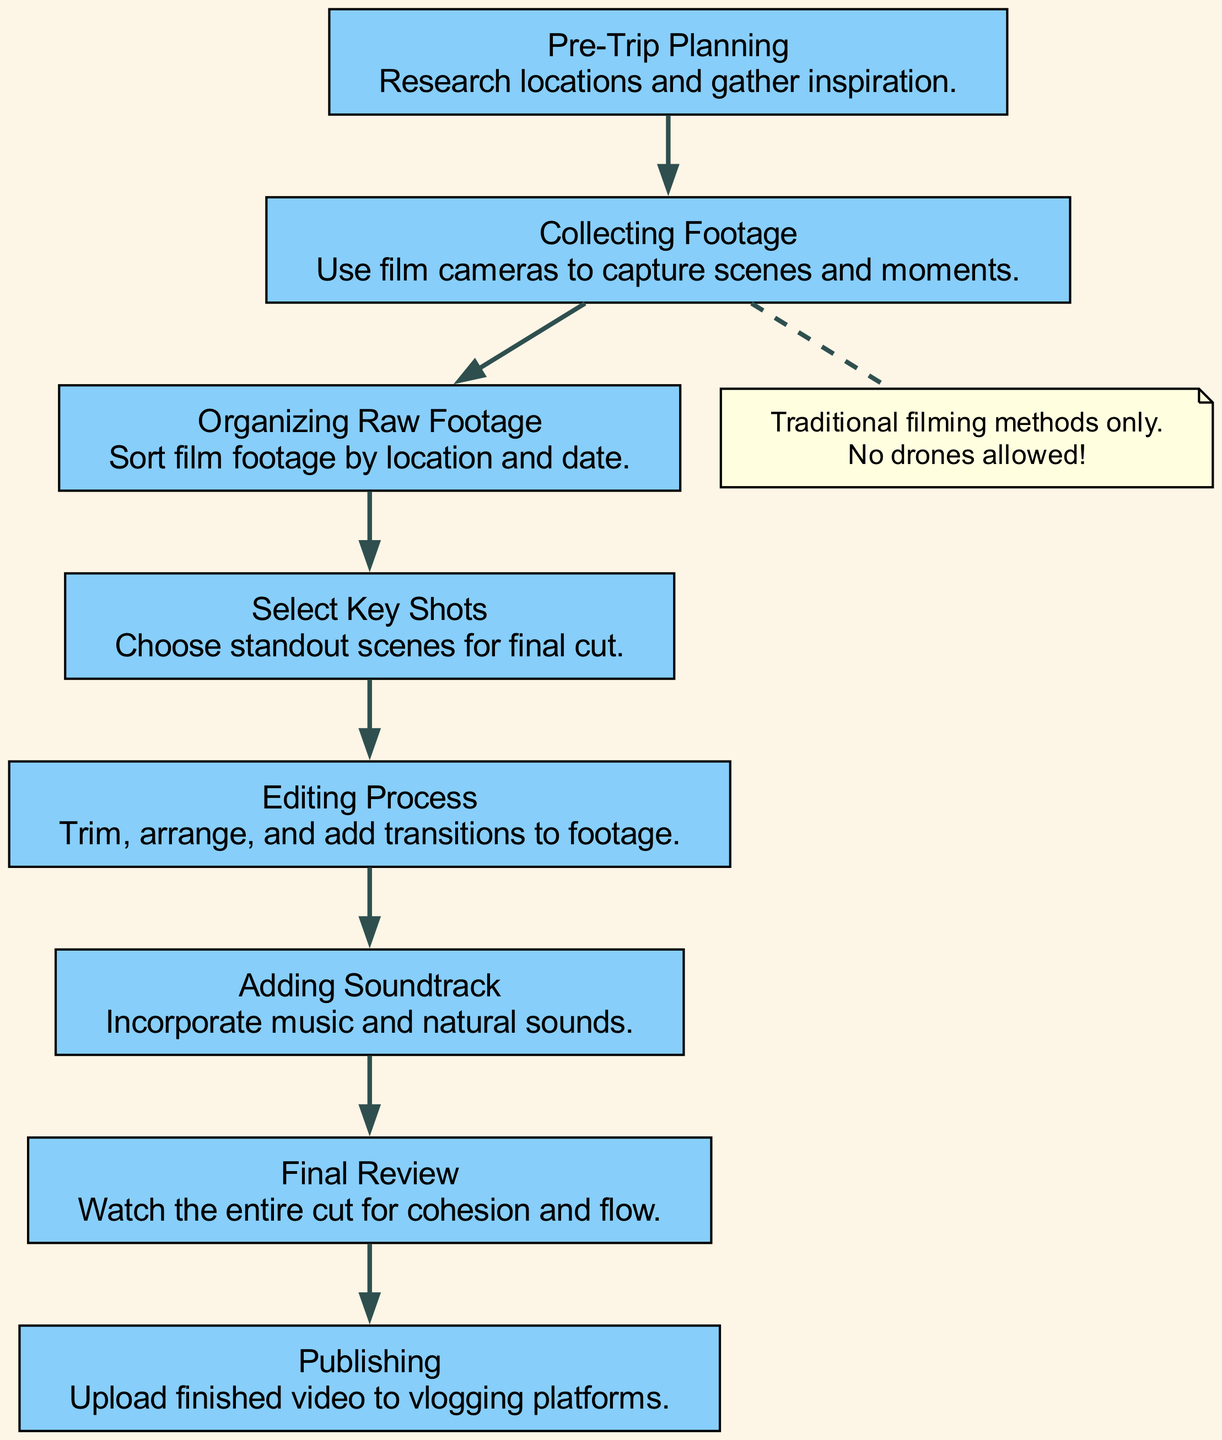What is the first step in the travel footage workflow? The diagram indicates that the first step is "Pre-Trip Planning," where the vlogger researches locations and gathers inspiration.
Answer: Pre-Trip Planning How many main steps are there in the workflow? By counting the main steps listed in the diagram, there are a total of eight steps shown, from "Pre-Trip Planning" to "Publishing."
Answer: Eight What follows "Collecting Footage" in the workflow? In the flow chart, "Organizing Raw Footage" directly follows "Collecting Footage," indicating the next step after capturing video.
Answer: Organizing Raw Footage Which step involves selecting standout scenes? The step labeled "Select Key Shots" focuses on choosing the best footage for the final cut.
Answer: Select Key Shots Which node is connected to the "Final Review" node? The "Publishing" node is connected to "Final Review," signifying the process of sharing the completed video on vlogging platforms.
Answer: Publishing What type of filming methods does the note mention? The note specifically mentions "Traditional filming methods only," which emphasizes the vlogger’s preference against drones.
Answer: Traditional filming methods only Which node does the diagram indicate is part of the editing process? The "Editing Process" node is part of the diagram and encompasses trimming, arranging, and adding transitions to the footage.
Answer: Editing Process What is the last step before publishing the video? According to the flow chart, the step "Final Review" is the last action before the video is published.
Answer: Final Review How does "Adding Soundtrack" relate to the overall workflow? "Adding Soundtrack" is a crucial part of the editing process, allowing the vlogger to enhance the footage with music and natural sounds.
Answer: Adding Soundtrack 